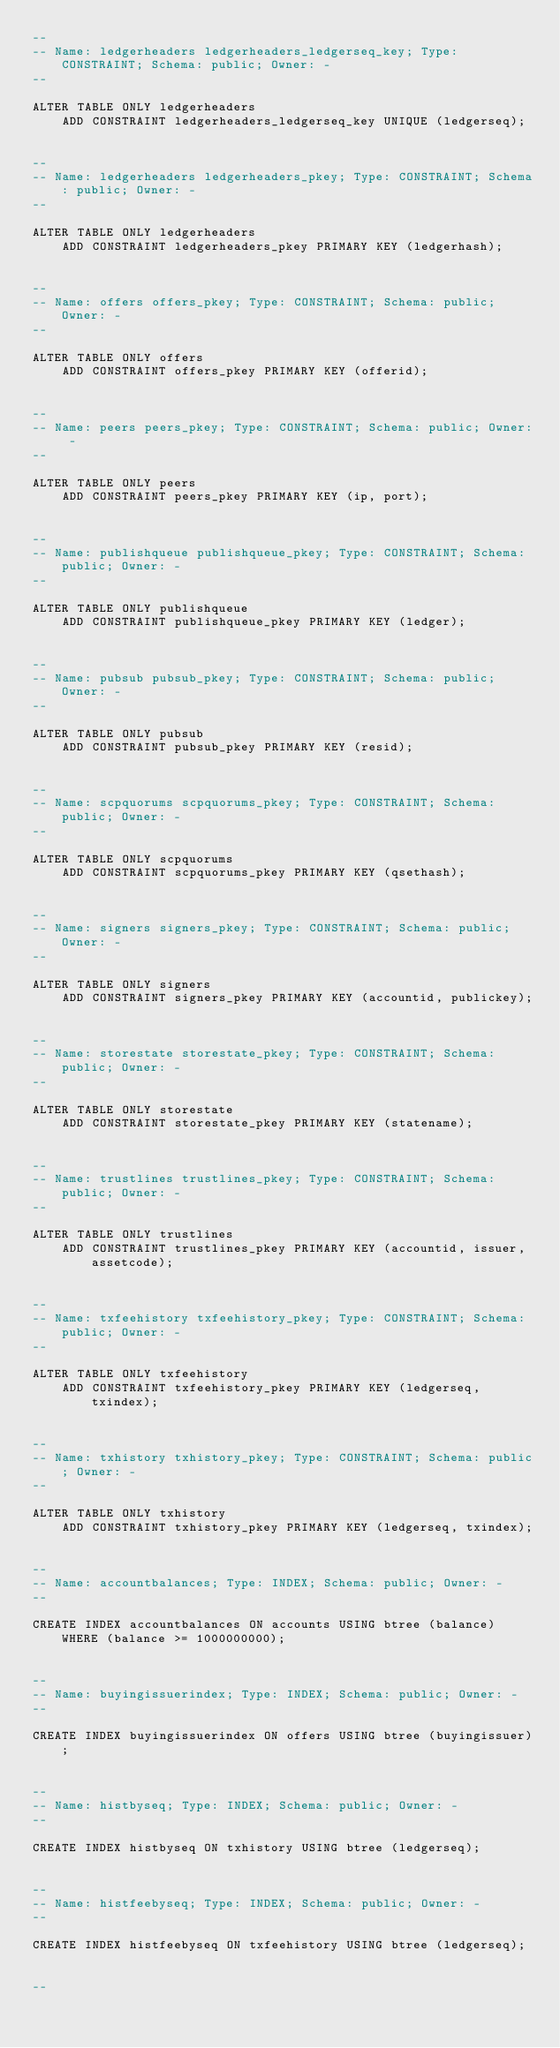<code> <loc_0><loc_0><loc_500><loc_500><_SQL_>--
-- Name: ledgerheaders ledgerheaders_ledgerseq_key; Type: CONSTRAINT; Schema: public; Owner: -
--

ALTER TABLE ONLY ledgerheaders
    ADD CONSTRAINT ledgerheaders_ledgerseq_key UNIQUE (ledgerseq);


--
-- Name: ledgerheaders ledgerheaders_pkey; Type: CONSTRAINT; Schema: public; Owner: -
--

ALTER TABLE ONLY ledgerheaders
    ADD CONSTRAINT ledgerheaders_pkey PRIMARY KEY (ledgerhash);


--
-- Name: offers offers_pkey; Type: CONSTRAINT; Schema: public; Owner: -
--

ALTER TABLE ONLY offers
    ADD CONSTRAINT offers_pkey PRIMARY KEY (offerid);


--
-- Name: peers peers_pkey; Type: CONSTRAINT; Schema: public; Owner: -
--

ALTER TABLE ONLY peers
    ADD CONSTRAINT peers_pkey PRIMARY KEY (ip, port);


--
-- Name: publishqueue publishqueue_pkey; Type: CONSTRAINT; Schema: public; Owner: -
--

ALTER TABLE ONLY publishqueue
    ADD CONSTRAINT publishqueue_pkey PRIMARY KEY (ledger);


--
-- Name: pubsub pubsub_pkey; Type: CONSTRAINT; Schema: public; Owner: -
--

ALTER TABLE ONLY pubsub
    ADD CONSTRAINT pubsub_pkey PRIMARY KEY (resid);


--
-- Name: scpquorums scpquorums_pkey; Type: CONSTRAINT; Schema: public; Owner: -
--

ALTER TABLE ONLY scpquorums
    ADD CONSTRAINT scpquorums_pkey PRIMARY KEY (qsethash);


--
-- Name: signers signers_pkey; Type: CONSTRAINT; Schema: public; Owner: -
--

ALTER TABLE ONLY signers
    ADD CONSTRAINT signers_pkey PRIMARY KEY (accountid, publickey);


--
-- Name: storestate storestate_pkey; Type: CONSTRAINT; Schema: public; Owner: -
--

ALTER TABLE ONLY storestate
    ADD CONSTRAINT storestate_pkey PRIMARY KEY (statename);


--
-- Name: trustlines trustlines_pkey; Type: CONSTRAINT; Schema: public; Owner: -
--

ALTER TABLE ONLY trustlines
    ADD CONSTRAINT trustlines_pkey PRIMARY KEY (accountid, issuer, assetcode);


--
-- Name: txfeehistory txfeehistory_pkey; Type: CONSTRAINT; Schema: public; Owner: -
--

ALTER TABLE ONLY txfeehistory
    ADD CONSTRAINT txfeehistory_pkey PRIMARY KEY (ledgerseq, txindex);


--
-- Name: txhistory txhistory_pkey; Type: CONSTRAINT; Schema: public; Owner: -
--

ALTER TABLE ONLY txhistory
    ADD CONSTRAINT txhistory_pkey PRIMARY KEY (ledgerseq, txindex);


--
-- Name: accountbalances; Type: INDEX; Schema: public; Owner: -
--

CREATE INDEX accountbalances ON accounts USING btree (balance) WHERE (balance >= 1000000000);


--
-- Name: buyingissuerindex; Type: INDEX; Schema: public; Owner: -
--

CREATE INDEX buyingissuerindex ON offers USING btree (buyingissuer);


--
-- Name: histbyseq; Type: INDEX; Schema: public; Owner: -
--

CREATE INDEX histbyseq ON txhistory USING btree (ledgerseq);


--
-- Name: histfeebyseq; Type: INDEX; Schema: public; Owner: -
--

CREATE INDEX histfeebyseq ON txfeehistory USING btree (ledgerseq);


--</code> 